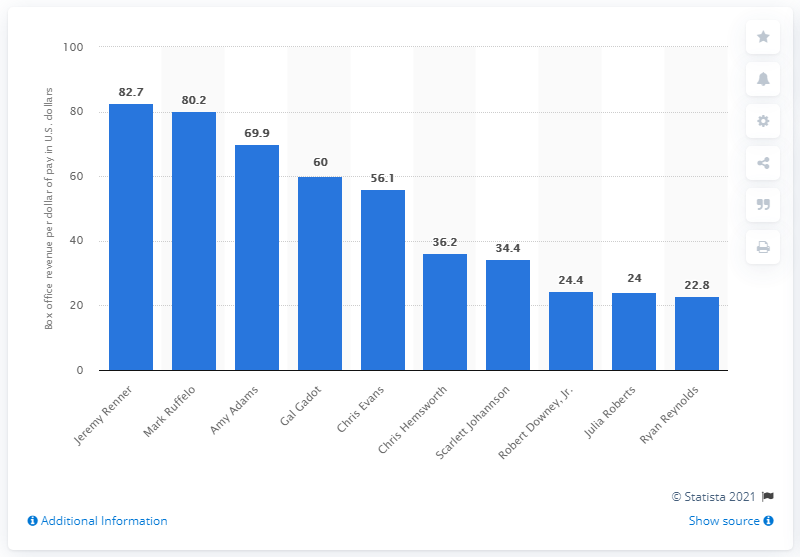Point out several critical features in this image. The best value actor in Hollywood in 2018 was Jeremy Renner, according to a list. 